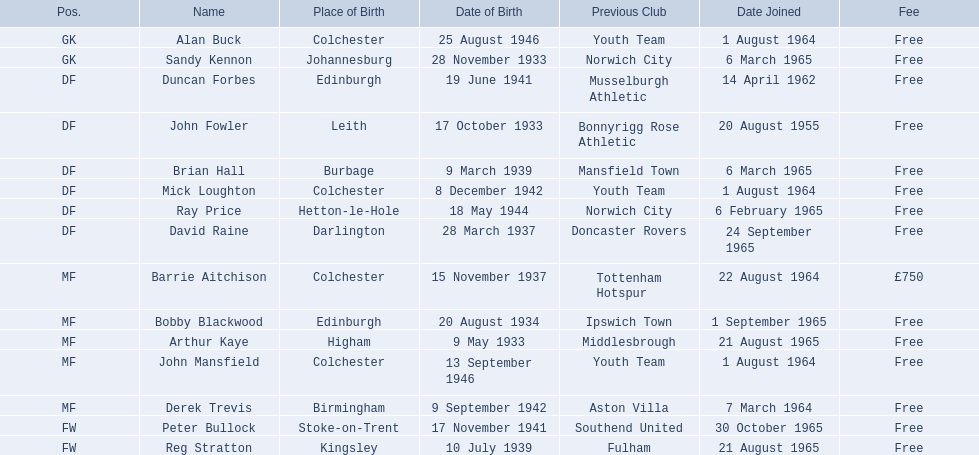Who are all the players? Alan Buck, Sandy Kennon, Duncan Forbes, John Fowler, Brian Hall, Mick Loughton, Ray Price, David Raine, Barrie Aitchison, Bobby Blackwood, Arthur Kaye, John Mansfield, Derek Trevis, Peter Bullock, Reg Stratton. What dates did the players join on? 1 August 1964, 6 March 1965, 14 April 1962, 20 August 1955, 6 March 1965, 1 August 1964, 6 February 1965, 24 September 1965, 22 August 1964, 1 September 1965, 21 August 1965, 1 August 1964, 7 March 1964, 30 October 1965, 21 August 1965. Who is the first player who joined? John Fowler. What is the date of the first person who joined? 20 August 1955. 